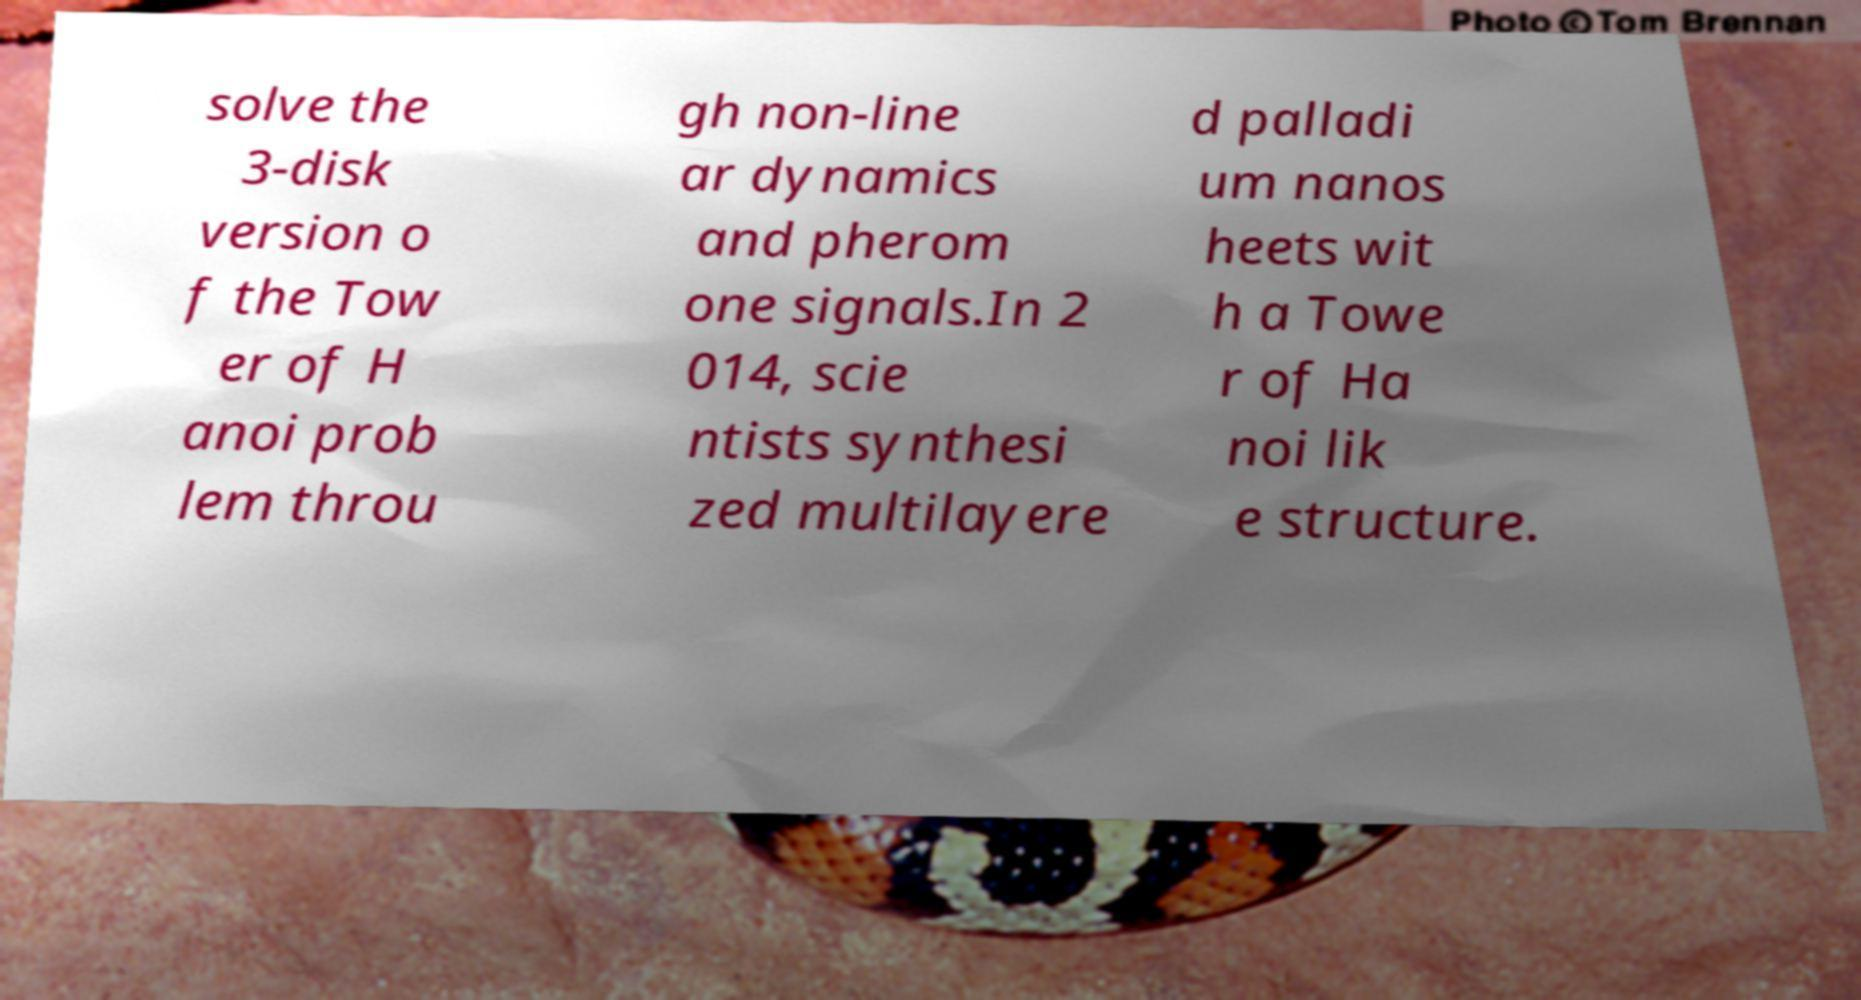Please identify and transcribe the text found in this image. solve the 3-disk version o f the Tow er of H anoi prob lem throu gh non-line ar dynamics and pherom one signals.In 2 014, scie ntists synthesi zed multilayere d palladi um nanos heets wit h a Towe r of Ha noi lik e structure. 